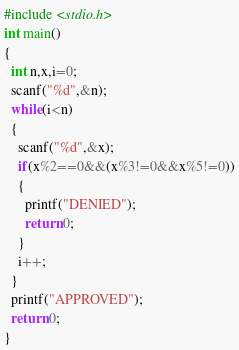Convert code to text. <code><loc_0><loc_0><loc_500><loc_500><_C_>#include <stdio.h>
int main()
{
  int n,x,i=0;
  scanf("%d",&n);
  while(i<n)
  {
    scanf("%d",&x);
    if(x%2==0&&(x%3!=0&&x%5!=0))
    {
      printf("DENIED");
      return 0;
    }
    i++;
  }
  printf("APPROVED");
  return 0;
}
</code> 